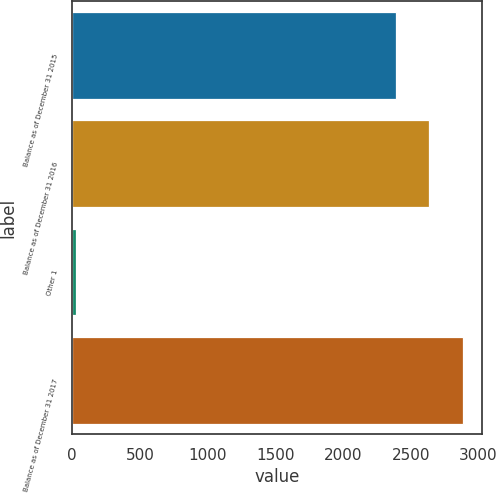<chart> <loc_0><loc_0><loc_500><loc_500><bar_chart><fcel>Balance as of December 31 2015<fcel>Balance as of December 31 2016<fcel>Other 1<fcel>Balance as of December 31 2017<nl><fcel>2392<fcel>2637.7<fcel>27<fcel>2883.4<nl></chart> 